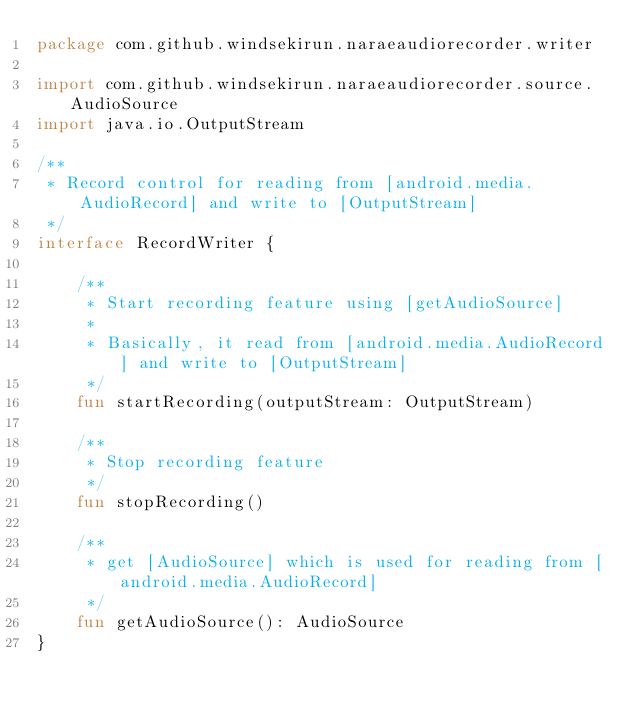Convert code to text. <code><loc_0><loc_0><loc_500><loc_500><_Kotlin_>package com.github.windsekirun.naraeaudiorecorder.writer

import com.github.windsekirun.naraeaudiorecorder.source.AudioSource
import java.io.OutputStream

/**
 * Record control for reading from [android.media.AudioRecord] and write to [OutputStream]
 */
interface RecordWriter {

    /**
     * Start recording feature using [getAudioSource]
     *
     * Basically, it read from [android.media.AudioRecord] and write to [OutputStream]
     */
    fun startRecording(outputStream: OutputStream)

    /**
     * Stop recording feature
     */
    fun stopRecording()

    /**
     * get [AudioSource] which is used for reading from [android.media.AudioRecord]
     */
    fun getAudioSource(): AudioSource
}</code> 